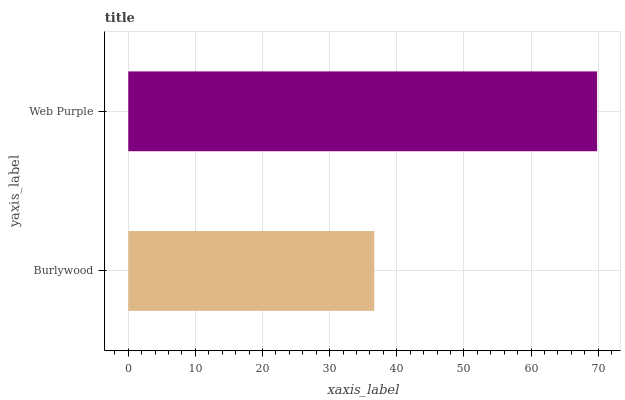Is Burlywood the minimum?
Answer yes or no. Yes. Is Web Purple the maximum?
Answer yes or no. Yes. Is Web Purple the minimum?
Answer yes or no. No. Is Web Purple greater than Burlywood?
Answer yes or no. Yes. Is Burlywood less than Web Purple?
Answer yes or no. Yes. Is Burlywood greater than Web Purple?
Answer yes or no. No. Is Web Purple less than Burlywood?
Answer yes or no. No. Is Web Purple the high median?
Answer yes or no. Yes. Is Burlywood the low median?
Answer yes or no. Yes. Is Burlywood the high median?
Answer yes or no. No. Is Web Purple the low median?
Answer yes or no. No. 